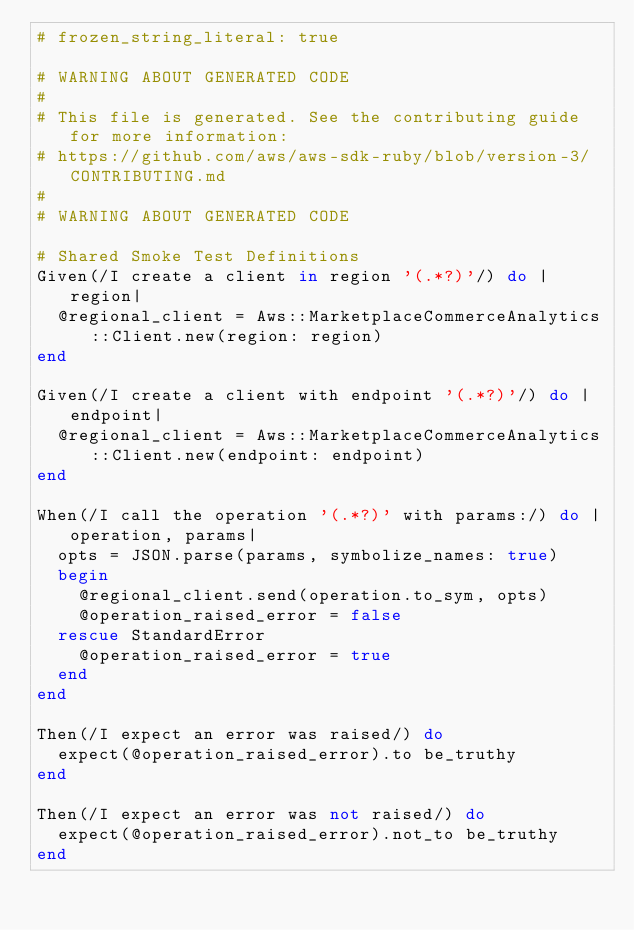<code> <loc_0><loc_0><loc_500><loc_500><_Ruby_># frozen_string_literal: true

# WARNING ABOUT GENERATED CODE
#
# This file is generated. See the contributing guide for more information:
# https://github.com/aws/aws-sdk-ruby/blob/version-3/CONTRIBUTING.md
#
# WARNING ABOUT GENERATED CODE

# Shared Smoke Test Definitions
Given(/I create a client in region '(.*?)'/) do |region|
  @regional_client = Aws::MarketplaceCommerceAnalytics::Client.new(region: region)
end

Given(/I create a client with endpoint '(.*?)'/) do |endpoint|
  @regional_client = Aws::MarketplaceCommerceAnalytics::Client.new(endpoint: endpoint)
end

When(/I call the operation '(.*?)' with params:/) do |operation, params|
  opts = JSON.parse(params, symbolize_names: true)
  begin
    @regional_client.send(operation.to_sym, opts)
    @operation_raised_error = false
  rescue StandardError
    @operation_raised_error = true
  end
end

Then(/I expect an error was raised/) do
  expect(@operation_raised_error).to be_truthy
end

Then(/I expect an error was not raised/) do
  expect(@operation_raised_error).not_to be_truthy
end
</code> 